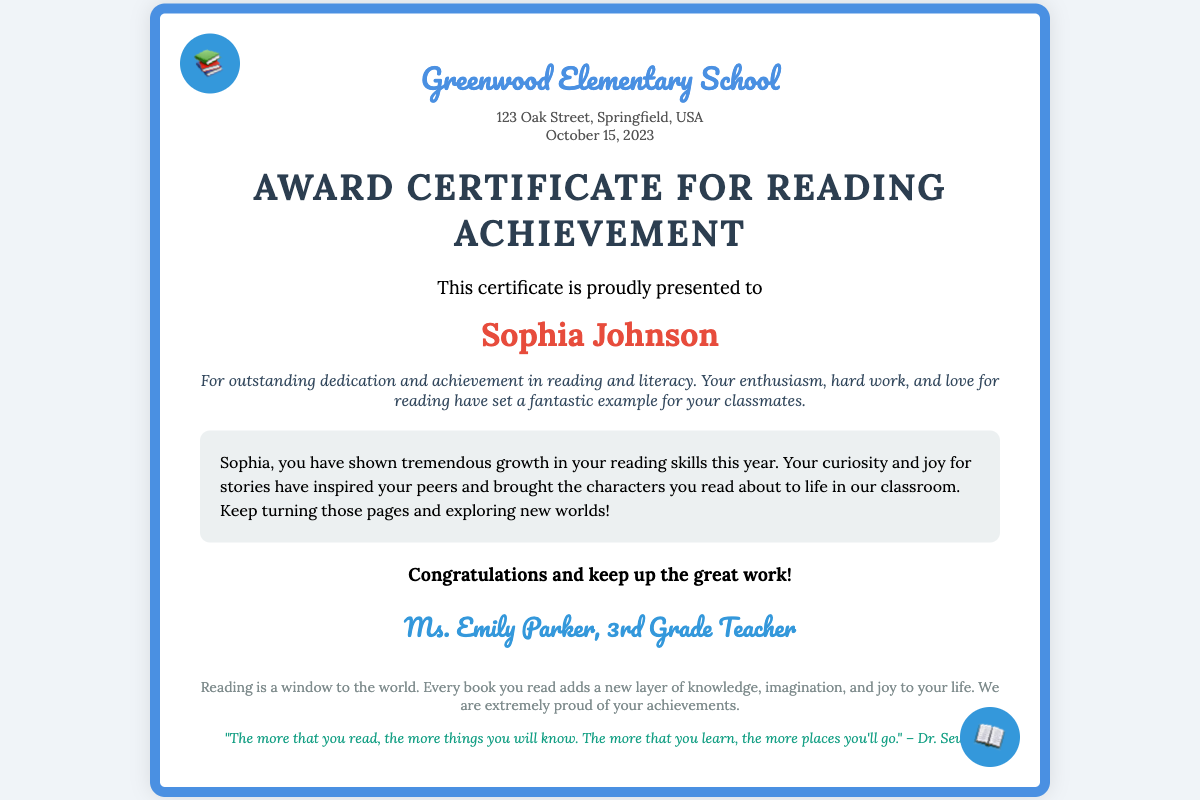What is the name of the student? The document clearly states the name of the student receiving the award.
Answer: Sophia Johnson What is the title of the certificate? The title is prominently displayed in large text, indicating what the certificate recognizes.
Answer: Award Certificate for Reading Achievement What is the date of the award? The date is specified in the document and shows when the award was presented.
Answer: October 15, 2023 Who is the teacher who signed the certificate? The teacher's signature section includes their name, indicating who acknowledged the student's achievement.
Answer: Ms. Emily Parker What is the school's name? The school name is clearly listed at the top of the certificate, identifying the institution.
Answer: Greenwood Elementary School What achievement is recognized in the certificate? The achievement summary explains the reason for the award, highlighting the student's accomplishments.
Answer: Dedication and achievement in reading and literacy What message is included for the student? The personalized message is meant to encourage and acknowledge the student’s efforts in literacy.
Answer: You have shown tremendous growth in your reading skills this year What is the inspirational quote at the bottom of the certificate? The document includes a quote that emphasizes the value of reading, found at the footer.
Answer: "The more that you read, the more things you will know." What kind of certificate is this? The document type is indicated by the title and the nature of its content.
Answer: Award Certificate 